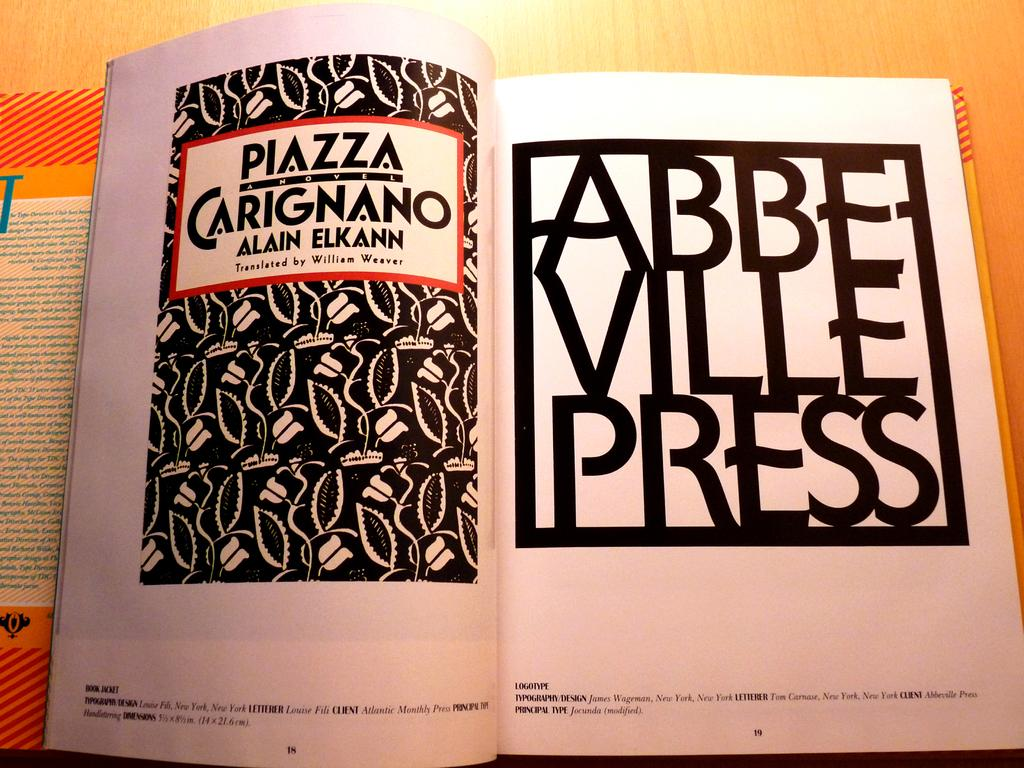<image>
Present a compact description of the photo's key features. An open book with some pictures that read ABBE VILLE PRESS. 